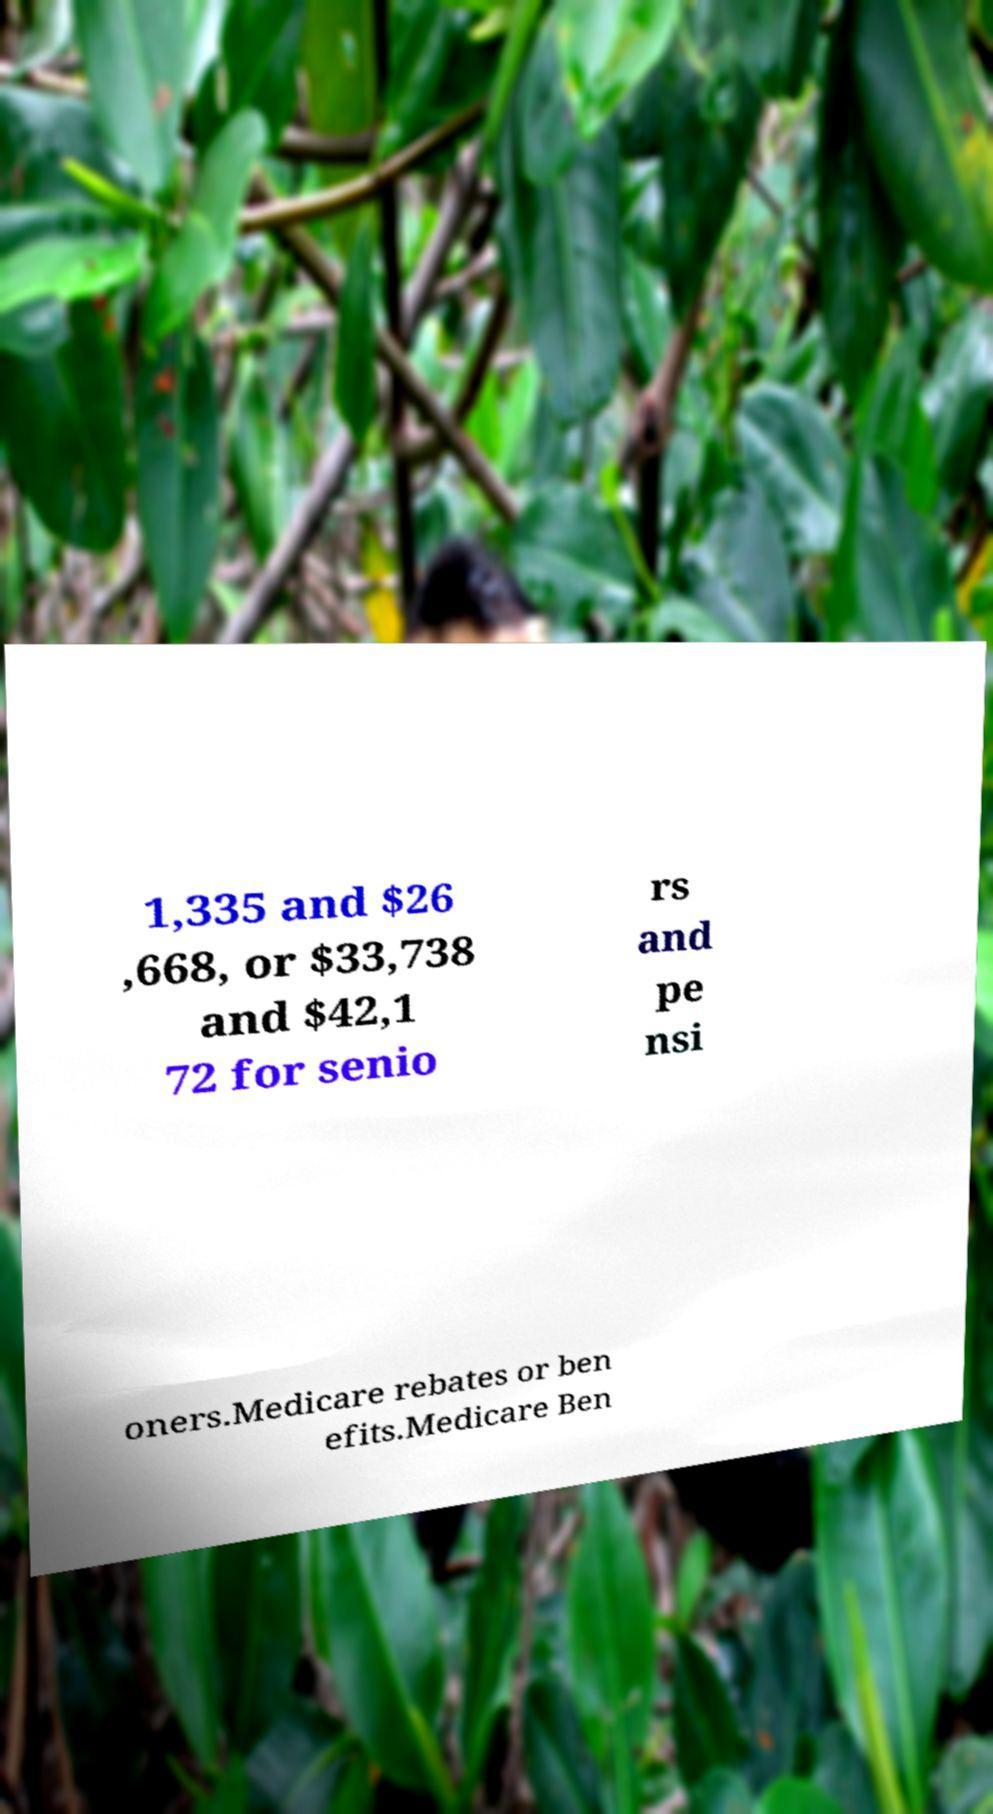I need the written content from this picture converted into text. Can you do that? 1,335 and $26 ,668, or $33,738 and $42,1 72 for senio rs and pe nsi oners.Medicare rebates or ben efits.Medicare Ben 